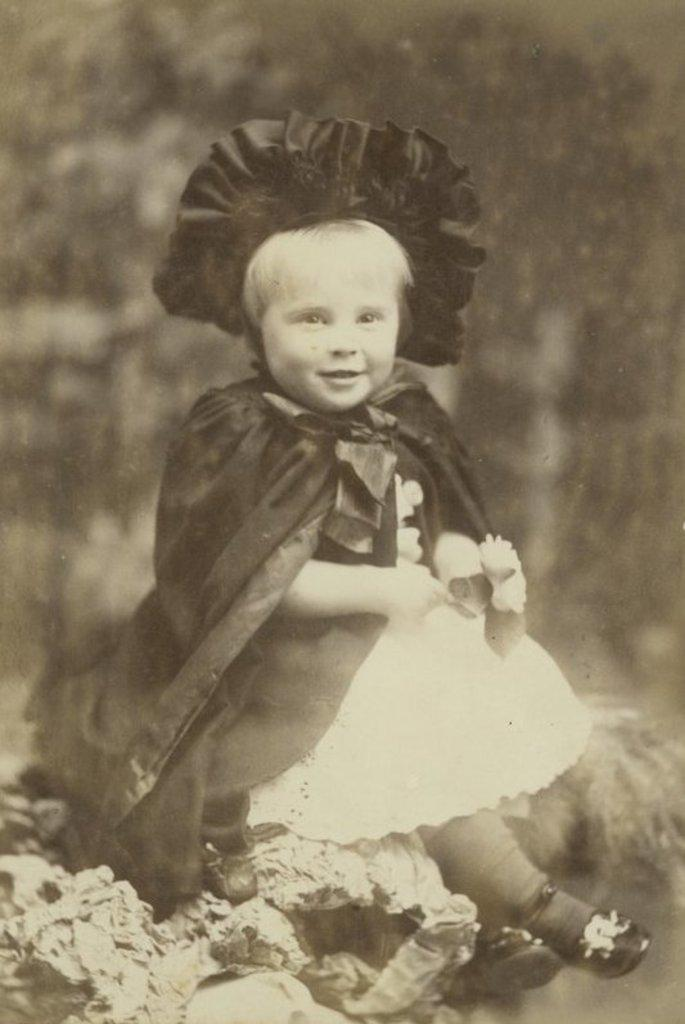What is the color scheme of the image? The image is a black and white photo. Who or what is the main subject of the image? There is a girl in the image. Can you describe the background of the image? The background of the image is blurred. What is the girl writing in the image? There is no indication in the image that the girl is writing anything. How many steps can be seen in the image? There are no steps visible in the image. 